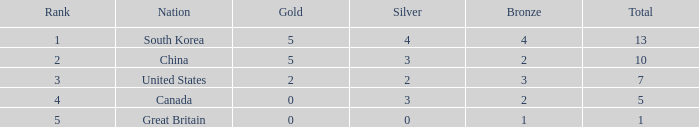What is the least rank, when nation is great britain, and when bronze is under 1? None. 